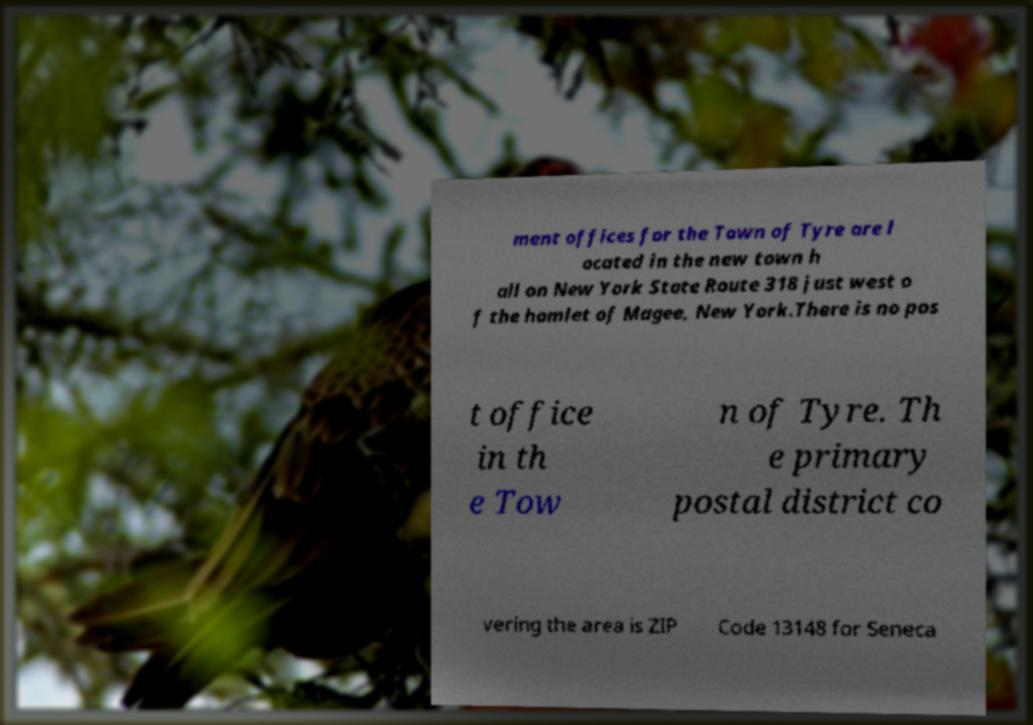Could you assist in decoding the text presented in this image and type it out clearly? ment offices for the Town of Tyre are l ocated in the new town h all on New York State Route 318 just west o f the hamlet of Magee, New York.There is no pos t office in th e Tow n of Tyre. Th e primary postal district co vering the area is ZIP Code 13148 for Seneca 